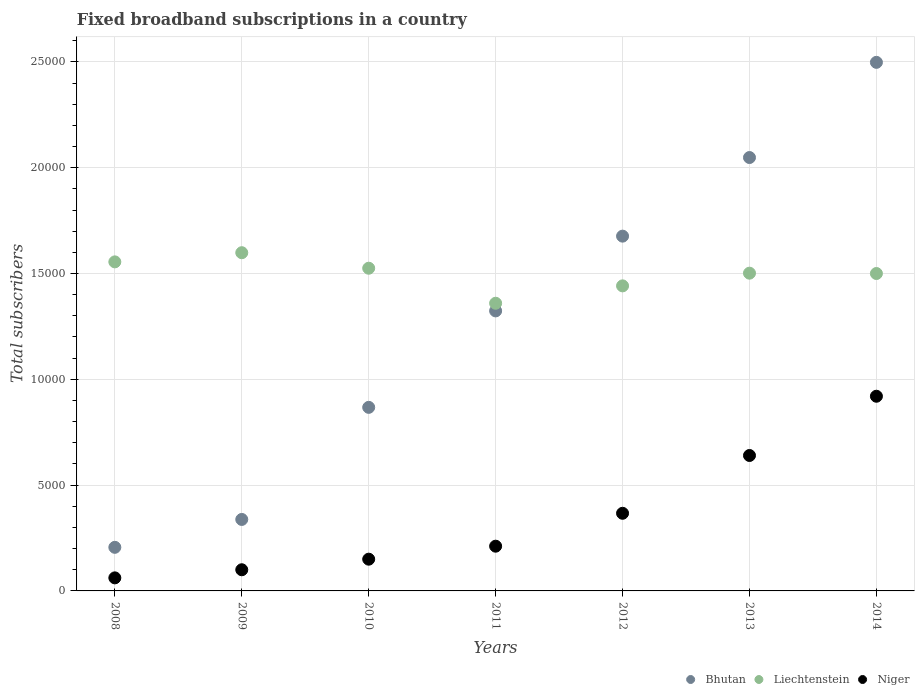How many different coloured dotlines are there?
Offer a terse response. 3. What is the number of broadband subscriptions in Niger in 2013?
Offer a very short reply. 6400. Across all years, what is the maximum number of broadband subscriptions in Liechtenstein?
Your answer should be very brief. 1.60e+04. Across all years, what is the minimum number of broadband subscriptions in Bhutan?
Make the answer very short. 2060. In which year was the number of broadband subscriptions in Niger maximum?
Keep it short and to the point. 2014. What is the total number of broadband subscriptions in Niger in the graph?
Your answer should be very brief. 2.45e+04. What is the difference between the number of broadband subscriptions in Bhutan in 2011 and that in 2014?
Your answer should be compact. -1.17e+04. What is the difference between the number of broadband subscriptions in Bhutan in 2011 and the number of broadband subscriptions in Niger in 2012?
Ensure brevity in your answer.  9564. What is the average number of broadband subscriptions in Niger per year?
Your answer should be very brief. 3500. In the year 2013, what is the difference between the number of broadband subscriptions in Liechtenstein and number of broadband subscriptions in Bhutan?
Your answer should be compact. -5465. In how many years, is the number of broadband subscriptions in Niger greater than 23000?
Offer a terse response. 0. What is the ratio of the number of broadband subscriptions in Niger in 2012 to that in 2013?
Offer a terse response. 0.57. Is the number of broadband subscriptions in Bhutan in 2011 less than that in 2013?
Provide a short and direct response. Yes. What is the difference between the highest and the second highest number of broadband subscriptions in Bhutan?
Offer a very short reply. 4498. What is the difference between the highest and the lowest number of broadband subscriptions in Niger?
Ensure brevity in your answer.  8583. In how many years, is the number of broadband subscriptions in Bhutan greater than the average number of broadband subscriptions in Bhutan taken over all years?
Your answer should be compact. 4. Does the number of broadband subscriptions in Niger monotonically increase over the years?
Provide a succinct answer. Yes. What is the difference between two consecutive major ticks on the Y-axis?
Offer a terse response. 5000. Where does the legend appear in the graph?
Offer a very short reply. Bottom right. How many legend labels are there?
Give a very brief answer. 3. What is the title of the graph?
Provide a succinct answer. Fixed broadband subscriptions in a country. Does "Kenya" appear as one of the legend labels in the graph?
Offer a very short reply. No. What is the label or title of the Y-axis?
Make the answer very short. Total subscribers. What is the Total subscribers in Bhutan in 2008?
Your response must be concise. 2060. What is the Total subscribers of Liechtenstein in 2008?
Provide a succinct answer. 1.56e+04. What is the Total subscribers of Niger in 2008?
Keep it short and to the point. 617. What is the Total subscribers in Bhutan in 2009?
Your response must be concise. 3378. What is the Total subscribers in Liechtenstein in 2009?
Provide a short and direct response. 1.60e+04. What is the Total subscribers in Niger in 2009?
Your answer should be compact. 1000. What is the Total subscribers in Bhutan in 2010?
Give a very brief answer. 8675. What is the Total subscribers in Liechtenstein in 2010?
Keep it short and to the point. 1.52e+04. What is the Total subscribers in Niger in 2010?
Offer a very short reply. 1500. What is the Total subscribers of Bhutan in 2011?
Your answer should be compact. 1.32e+04. What is the Total subscribers in Liechtenstein in 2011?
Offer a terse response. 1.36e+04. What is the Total subscribers of Niger in 2011?
Your answer should be very brief. 2114. What is the Total subscribers of Bhutan in 2012?
Offer a very short reply. 1.68e+04. What is the Total subscribers in Liechtenstein in 2012?
Offer a very short reply. 1.44e+04. What is the Total subscribers of Niger in 2012?
Make the answer very short. 3669. What is the Total subscribers in Bhutan in 2013?
Ensure brevity in your answer.  2.05e+04. What is the Total subscribers of Liechtenstein in 2013?
Offer a very short reply. 1.50e+04. What is the Total subscribers of Niger in 2013?
Make the answer very short. 6400. What is the Total subscribers of Bhutan in 2014?
Offer a terse response. 2.50e+04. What is the Total subscribers of Liechtenstein in 2014?
Offer a very short reply. 1.50e+04. What is the Total subscribers of Niger in 2014?
Give a very brief answer. 9200. Across all years, what is the maximum Total subscribers of Bhutan?
Make the answer very short. 2.50e+04. Across all years, what is the maximum Total subscribers in Liechtenstein?
Provide a short and direct response. 1.60e+04. Across all years, what is the maximum Total subscribers in Niger?
Offer a terse response. 9200. Across all years, what is the minimum Total subscribers in Bhutan?
Offer a terse response. 2060. Across all years, what is the minimum Total subscribers of Liechtenstein?
Your response must be concise. 1.36e+04. Across all years, what is the minimum Total subscribers in Niger?
Offer a terse response. 617. What is the total Total subscribers in Bhutan in the graph?
Your answer should be very brief. 8.96e+04. What is the total Total subscribers of Liechtenstein in the graph?
Provide a short and direct response. 1.05e+05. What is the total Total subscribers in Niger in the graph?
Ensure brevity in your answer.  2.45e+04. What is the difference between the Total subscribers in Bhutan in 2008 and that in 2009?
Offer a terse response. -1318. What is the difference between the Total subscribers of Liechtenstein in 2008 and that in 2009?
Offer a terse response. -433. What is the difference between the Total subscribers of Niger in 2008 and that in 2009?
Provide a short and direct response. -383. What is the difference between the Total subscribers of Bhutan in 2008 and that in 2010?
Your response must be concise. -6615. What is the difference between the Total subscribers of Liechtenstein in 2008 and that in 2010?
Ensure brevity in your answer.  300. What is the difference between the Total subscribers of Niger in 2008 and that in 2010?
Provide a short and direct response. -883. What is the difference between the Total subscribers of Bhutan in 2008 and that in 2011?
Offer a terse response. -1.12e+04. What is the difference between the Total subscribers of Liechtenstein in 2008 and that in 2011?
Ensure brevity in your answer.  1955. What is the difference between the Total subscribers of Niger in 2008 and that in 2011?
Provide a succinct answer. -1497. What is the difference between the Total subscribers of Bhutan in 2008 and that in 2012?
Offer a very short reply. -1.47e+04. What is the difference between the Total subscribers in Liechtenstein in 2008 and that in 2012?
Keep it short and to the point. 1134. What is the difference between the Total subscribers in Niger in 2008 and that in 2012?
Make the answer very short. -3052. What is the difference between the Total subscribers in Bhutan in 2008 and that in 2013?
Make the answer very short. -1.84e+04. What is the difference between the Total subscribers of Liechtenstein in 2008 and that in 2013?
Offer a very short reply. 534. What is the difference between the Total subscribers of Niger in 2008 and that in 2013?
Give a very brief answer. -5783. What is the difference between the Total subscribers of Bhutan in 2008 and that in 2014?
Provide a succinct answer. -2.29e+04. What is the difference between the Total subscribers in Liechtenstein in 2008 and that in 2014?
Give a very brief answer. 550. What is the difference between the Total subscribers of Niger in 2008 and that in 2014?
Your response must be concise. -8583. What is the difference between the Total subscribers of Bhutan in 2009 and that in 2010?
Ensure brevity in your answer.  -5297. What is the difference between the Total subscribers in Liechtenstein in 2009 and that in 2010?
Your answer should be compact. 733. What is the difference between the Total subscribers of Niger in 2009 and that in 2010?
Make the answer very short. -500. What is the difference between the Total subscribers in Bhutan in 2009 and that in 2011?
Provide a short and direct response. -9855. What is the difference between the Total subscribers in Liechtenstein in 2009 and that in 2011?
Offer a very short reply. 2388. What is the difference between the Total subscribers in Niger in 2009 and that in 2011?
Make the answer very short. -1114. What is the difference between the Total subscribers in Bhutan in 2009 and that in 2012?
Ensure brevity in your answer.  -1.34e+04. What is the difference between the Total subscribers of Liechtenstein in 2009 and that in 2012?
Make the answer very short. 1567. What is the difference between the Total subscribers in Niger in 2009 and that in 2012?
Give a very brief answer. -2669. What is the difference between the Total subscribers in Bhutan in 2009 and that in 2013?
Provide a succinct answer. -1.71e+04. What is the difference between the Total subscribers of Liechtenstein in 2009 and that in 2013?
Offer a terse response. 967. What is the difference between the Total subscribers in Niger in 2009 and that in 2013?
Your response must be concise. -5400. What is the difference between the Total subscribers in Bhutan in 2009 and that in 2014?
Make the answer very short. -2.16e+04. What is the difference between the Total subscribers of Liechtenstein in 2009 and that in 2014?
Your answer should be very brief. 983. What is the difference between the Total subscribers in Niger in 2009 and that in 2014?
Offer a terse response. -8200. What is the difference between the Total subscribers in Bhutan in 2010 and that in 2011?
Your answer should be compact. -4558. What is the difference between the Total subscribers of Liechtenstein in 2010 and that in 2011?
Provide a short and direct response. 1655. What is the difference between the Total subscribers in Niger in 2010 and that in 2011?
Offer a very short reply. -614. What is the difference between the Total subscribers of Bhutan in 2010 and that in 2012?
Make the answer very short. -8091. What is the difference between the Total subscribers of Liechtenstein in 2010 and that in 2012?
Offer a very short reply. 834. What is the difference between the Total subscribers in Niger in 2010 and that in 2012?
Your answer should be very brief. -2169. What is the difference between the Total subscribers of Bhutan in 2010 and that in 2013?
Ensure brevity in your answer.  -1.18e+04. What is the difference between the Total subscribers in Liechtenstein in 2010 and that in 2013?
Ensure brevity in your answer.  234. What is the difference between the Total subscribers of Niger in 2010 and that in 2013?
Give a very brief answer. -4900. What is the difference between the Total subscribers in Bhutan in 2010 and that in 2014?
Give a very brief answer. -1.63e+04. What is the difference between the Total subscribers in Liechtenstein in 2010 and that in 2014?
Make the answer very short. 250. What is the difference between the Total subscribers in Niger in 2010 and that in 2014?
Offer a terse response. -7700. What is the difference between the Total subscribers in Bhutan in 2011 and that in 2012?
Give a very brief answer. -3533. What is the difference between the Total subscribers of Liechtenstein in 2011 and that in 2012?
Keep it short and to the point. -821. What is the difference between the Total subscribers in Niger in 2011 and that in 2012?
Provide a short and direct response. -1555. What is the difference between the Total subscribers in Bhutan in 2011 and that in 2013?
Offer a terse response. -7248. What is the difference between the Total subscribers of Liechtenstein in 2011 and that in 2013?
Offer a terse response. -1421. What is the difference between the Total subscribers in Niger in 2011 and that in 2013?
Give a very brief answer. -4286. What is the difference between the Total subscribers in Bhutan in 2011 and that in 2014?
Give a very brief answer. -1.17e+04. What is the difference between the Total subscribers of Liechtenstein in 2011 and that in 2014?
Your answer should be very brief. -1405. What is the difference between the Total subscribers in Niger in 2011 and that in 2014?
Your answer should be very brief. -7086. What is the difference between the Total subscribers in Bhutan in 2012 and that in 2013?
Keep it short and to the point. -3715. What is the difference between the Total subscribers in Liechtenstein in 2012 and that in 2013?
Offer a very short reply. -600. What is the difference between the Total subscribers in Niger in 2012 and that in 2013?
Your response must be concise. -2731. What is the difference between the Total subscribers of Bhutan in 2012 and that in 2014?
Your response must be concise. -8213. What is the difference between the Total subscribers in Liechtenstein in 2012 and that in 2014?
Offer a terse response. -584. What is the difference between the Total subscribers in Niger in 2012 and that in 2014?
Make the answer very short. -5531. What is the difference between the Total subscribers in Bhutan in 2013 and that in 2014?
Provide a succinct answer. -4498. What is the difference between the Total subscribers of Liechtenstein in 2013 and that in 2014?
Your answer should be compact. 16. What is the difference between the Total subscribers in Niger in 2013 and that in 2014?
Provide a short and direct response. -2800. What is the difference between the Total subscribers in Bhutan in 2008 and the Total subscribers in Liechtenstein in 2009?
Your answer should be very brief. -1.39e+04. What is the difference between the Total subscribers in Bhutan in 2008 and the Total subscribers in Niger in 2009?
Keep it short and to the point. 1060. What is the difference between the Total subscribers of Liechtenstein in 2008 and the Total subscribers of Niger in 2009?
Give a very brief answer. 1.46e+04. What is the difference between the Total subscribers in Bhutan in 2008 and the Total subscribers in Liechtenstein in 2010?
Make the answer very short. -1.32e+04. What is the difference between the Total subscribers of Bhutan in 2008 and the Total subscribers of Niger in 2010?
Provide a succinct answer. 560. What is the difference between the Total subscribers of Liechtenstein in 2008 and the Total subscribers of Niger in 2010?
Offer a terse response. 1.40e+04. What is the difference between the Total subscribers of Bhutan in 2008 and the Total subscribers of Liechtenstein in 2011?
Offer a terse response. -1.15e+04. What is the difference between the Total subscribers of Bhutan in 2008 and the Total subscribers of Niger in 2011?
Give a very brief answer. -54. What is the difference between the Total subscribers in Liechtenstein in 2008 and the Total subscribers in Niger in 2011?
Provide a short and direct response. 1.34e+04. What is the difference between the Total subscribers in Bhutan in 2008 and the Total subscribers in Liechtenstein in 2012?
Provide a short and direct response. -1.24e+04. What is the difference between the Total subscribers of Bhutan in 2008 and the Total subscribers of Niger in 2012?
Give a very brief answer. -1609. What is the difference between the Total subscribers of Liechtenstein in 2008 and the Total subscribers of Niger in 2012?
Your answer should be compact. 1.19e+04. What is the difference between the Total subscribers in Bhutan in 2008 and the Total subscribers in Liechtenstein in 2013?
Make the answer very short. -1.30e+04. What is the difference between the Total subscribers of Bhutan in 2008 and the Total subscribers of Niger in 2013?
Provide a succinct answer. -4340. What is the difference between the Total subscribers in Liechtenstein in 2008 and the Total subscribers in Niger in 2013?
Make the answer very short. 9150. What is the difference between the Total subscribers in Bhutan in 2008 and the Total subscribers in Liechtenstein in 2014?
Your answer should be very brief. -1.29e+04. What is the difference between the Total subscribers of Bhutan in 2008 and the Total subscribers of Niger in 2014?
Your response must be concise. -7140. What is the difference between the Total subscribers in Liechtenstein in 2008 and the Total subscribers in Niger in 2014?
Your answer should be compact. 6350. What is the difference between the Total subscribers of Bhutan in 2009 and the Total subscribers of Liechtenstein in 2010?
Offer a very short reply. -1.19e+04. What is the difference between the Total subscribers of Bhutan in 2009 and the Total subscribers of Niger in 2010?
Give a very brief answer. 1878. What is the difference between the Total subscribers in Liechtenstein in 2009 and the Total subscribers in Niger in 2010?
Your response must be concise. 1.45e+04. What is the difference between the Total subscribers in Bhutan in 2009 and the Total subscribers in Liechtenstein in 2011?
Your answer should be very brief. -1.02e+04. What is the difference between the Total subscribers in Bhutan in 2009 and the Total subscribers in Niger in 2011?
Offer a very short reply. 1264. What is the difference between the Total subscribers in Liechtenstein in 2009 and the Total subscribers in Niger in 2011?
Provide a succinct answer. 1.39e+04. What is the difference between the Total subscribers of Bhutan in 2009 and the Total subscribers of Liechtenstein in 2012?
Ensure brevity in your answer.  -1.10e+04. What is the difference between the Total subscribers of Bhutan in 2009 and the Total subscribers of Niger in 2012?
Provide a short and direct response. -291. What is the difference between the Total subscribers of Liechtenstein in 2009 and the Total subscribers of Niger in 2012?
Keep it short and to the point. 1.23e+04. What is the difference between the Total subscribers in Bhutan in 2009 and the Total subscribers in Liechtenstein in 2013?
Your answer should be very brief. -1.16e+04. What is the difference between the Total subscribers of Bhutan in 2009 and the Total subscribers of Niger in 2013?
Provide a succinct answer. -3022. What is the difference between the Total subscribers of Liechtenstein in 2009 and the Total subscribers of Niger in 2013?
Provide a short and direct response. 9583. What is the difference between the Total subscribers of Bhutan in 2009 and the Total subscribers of Liechtenstein in 2014?
Your response must be concise. -1.16e+04. What is the difference between the Total subscribers of Bhutan in 2009 and the Total subscribers of Niger in 2014?
Your response must be concise. -5822. What is the difference between the Total subscribers of Liechtenstein in 2009 and the Total subscribers of Niger in 2014?
Make the answer very short. 6783. What is the difference between the Total subscribers of Bhutan in 2010 and the Total subscribers of Liechtenstein in 2011?
Offer a very short reply. -4920. What is the difference between the Total subscribers of Bhutan in 2010 and the Total subscribers of Niger in 2011?
Your answer should be compact. 6561. What is the difference between the Total subscribers in Liechtenstein in 2010 and the Total subscribers in Niger in 2011?
Provide a short and direct response. 1.31e+04. What is the difference between the Total subscribers in Bhutan in 2010 and the Total subscribers in Liechtenstein in 2012?
Your answer should be very brief. -5741. What is the difference between the Total subscribers of Bhutan in 2010 and the Total subscribers of Niger in 2012?
Make the answer very short. 5006. What is the difference between the Total subscribers of Liechtenstein in 2010 and the Total subscribers of Niger in 2012?
Your response must be concise. 1.16e+04. What is the difference between the Total subscribers of Bhutan in 2010 and the Total subscribers of Liechtenstein in 2013?
Offer a very short reply. -6341. What is the difference between the Total subscribers of Bhutan in 2010 and the Total subscribers of Niger in 2013?
Your answer should be compact. 2275. What is the difference between the Total subscribers of Liechtenstein in 2010 and the Total subscribers of Niger in 2013?
Give a very brief answer. 8850. What is the difference between the Total subscribers of Bhutan in 2010 and the Total subscribers of Liechtenstein in 2014?
Your response must be concise. -6325. What is the difference between the Total subscribers in Bhutan in 2010 and the Total subscribers in Niger in 2014?
Ensure brevity in your answer.  -525. What is the difference between the Total subscribers of Liechtenstein in 2010 and the Total subscribers of Niger in 2014?
Offer a terse response. 6050. What is the difference between the Total subscribers in Bhutan in 2011 and the Total subscribers in Liechtenstein in 2012?
Your answer should be compact. -1183. What is the difference between the Total subscribers of Bhutan in 2011 and the Total subscribers of Niger in 2012?
Offer a terse response. 9564. What is the difference between the Total subscribers in Liechtenstein in 2011 and the Total subscribers in Niger in 2012?
Your answer should be compact. 9926. What is the difference between the Total subscribers of Bhutan in 2011 and the Total subscribers of Liechtenstein in 2013?
Ensure brevity in your answer.  -1783. What is the difference between the Total subscribers in Bhutan in 2011 and the Total subscribers in Niger in 2013?
Offer a very short reply. 6833. What is the difference between the Total subscribers in Liechtenstein in 2011 and the Total subscribers in Niger in 2013?
Make the answer very short. 7195. What is the difference between the Total subscribers of Bhutan in 2011 and the Total subscribers of Liechtenstein in 2014?
Provide a succinct answer. -1767. What is the difference between the Total subscribers in Bhutan in 2011 and the Total subscribers in Niger in 2014?
Your answer should be very brief. 4033. What is the difference between the Total subscribers of Liechtenstein in 2011 and the Total subscribers of Niger in 2014?
Offer a very short reply. 4395. What is the difference between the Total subscribers in Bhutan in 2012 and the Total subscribers in Liechtenstein in 2013?
Offer a very short reply. 1750. What is the difference between the Total subscribers in Bhutan in 2012 and the Total subscribers in Niger in 2013?
Keep it short and to the point. 1.04e+04. What is the difference between the Total subscribers in Liechtenstein in 2012 and the Total subscribers in Niger in 2013?
Provide a succinct answer. 8016. What is the difference between the Total subscribers of Bhutan in 2012 and the Total subscribers of Liechtenstein in 2014?
Ensure brevity in your answer.  1766. What is the difference between the Total subscribers of Bhutan in 2012 and the Total subscribers of Niger in 2014?
Provide a succinct answer. 7566. What is the difference between the Total subscribers of Liechtenstein in 2012 and the Total subscribers of Niger in 2014?
Keep it short and to the point. 5216. What is the difference between the Total subscribers of Bhutan in 2013 and the Total subscribers of Liechtenstein in 2014?
Your response must be concise. 5481. What is the difference between the Total subscribers in Bhutan in 2013 and the Total subscribers in Niger in 2014?
Keep it short and to the point. 1.13e+04. What is the difference between the Total subscribers in Liechtenstein in 2013 and the Total subscribers in Niger in 2014?
Your answer should be compact. 5816. What is the average Total subscribers in Bhutan per year?
Ensure brevity in your answer.  1.28e+04. What is the average Total subscribers of Liechtenstein per year?
Offer a terse response. 1.50e+04. What is the average Total subscribers in Niger per year?
Keep it short and to the point. 3500. In the year 2008, what is the difference between the Total subscribers in Bhutan and Total subscribers in Liechtenstein?
Provide a succinct answer. -1.35e+04. In the year 2008, what is the difference between the Total subscribers in Bhutan and Total subscribers in Niger?
Your response must be concise. 1443. In the year 2008, what is the difference between the Total subscribers of Liechtenstein and Total subscribers of Niger?
Provide a succinct answer. 1.49e+04. In the year 2009, what is the difference between the Total subscribers in Bhutan and Total subscribers in Liechtenstein?
Ensure brevity in your answer.  -1.26e+04. In the year 2009, what is the difference between the Total subscribers in Bhutan and Total subscribers in Niger?
Offer a very short reply. 2378. In the year 2009, what is the difference between the Total subscribers of Liechtenstein and Total subscribers of Niger?
Provide a short and direct response. 1.50e+04. In the year 2010, what is the difference between the Total subscribers in Bhutan and Total subscribers in Liechtenstein?
Provide a short and direct response. -6575. In the year 2010, what is the difference between the Total subscribers in Bhutan and Total subscribers in Niger?
Offer a terse response. 7175. In the year 2010, what is the difference between the Total subscribers of Liechtenstein and Total subscribers of Niger?
Provide a succinct answer. 1.38e+04. In the year 2011, what is the difference between the Total subscribers of Bhutan and Total subscribers of Liechtenstein?
Your answer should be compact. -362. In the year 2011, what is the difference between the Total subscribers in Bhutan and Total subscribers in Niger?
Make the answer very short. 1.11e+04. In the year 2011, what is the difference between the Total subscribers in Liechtenstein and Total subscribers in Niger?
Make the answer very short. 1.15e+04. In the year 2012, what is the difference between the Total subscribers in Bhutan and Total subscribers in Liechtenstein?
Provide a succinct answer. 2350. In the year 2012, what is the difference between the Total subscribers of Bhutan and Total subscribers of Niger?
Provide a short and direct response. 1.31e+04. In the year 2012, what is the difference between the Total subscribers of Liechtenstein and Total subscribers of Niger?
Ensure brevity in your answer.  1.07e+04. In the year 2013, what is the difference between the Total subscribers in Bhutan and Total subscribers in Liechtenstein?
Your response must be concise. 5465. In the year 2013, what is the difference between the Total subscribers in Bhutan and Total subscribers in Niger?
Your answer should be compact. 1.41e+04. In the year 2013, what is the difference between the Total subscribers of Liechtenstein and Total subscribers of Niger?
Provide a succinct answer. 8616. In the year 2014, what is the difference between the Total subscribers in Bhutan and Total subscribers in Liechtenstein?
Your answer should be very brief. 9979. In the year 2014, what is the difference between the Total subscribers of Bhutan and Total subscribers of Niger?
Your response must be concise. 1.58e+04. In the year 2014, what is the difference between the Total subscribers of Liechtenstein and Total subscribers of Niger?
Your response must be concise. 5800. What is the ratio of the Total subscribers of Bhutan in 2008 to that in 2009?
Keep it short and to the point. 0.61. What is the ratio of the Total subscribers in Liechtenstein in 2008 to that in 2009?
Ensure brevity in your answer.  0.97. What is the ratio of the Total subscribers in Niger in 2008 to that in 2009?
Ensure brevity in your answer.  0.62. What is the ratio of the Total subscribers in Bhutan in 2008 to that in 2010?
Your answer should be compact. 0.24. What is the ratio of the Total subscribers in Liechtenstein in 2008 to that in 2010?
Your response must be concise. 1.02. What is the ratio of the Total subscribers in Niger in 2008 to that in 2010?
Your answer should be compact. 0.41. What is the ratio of the Total subscribers in Bhutan in 2008 to that in 2011?
Provide a succinct answer. 0.16. What is the ratio of the Total subscribers of Liechtenstein in 2008 to that in 2011?
Keep it short and to the point. 1.14. What is the ratio of the Total subscribers of Niger in 2008 to that in 2011?
Provide a short and direct response. 0.29. What is the ratio of the Total subscribers of Bhutan in 2008 to that in 2012?
Offer a terse response. 0.12. What is the ratio of the Total subscribers of Liechtenstein in 2008 to that in 2012?
Your answer should be very brief. 1.08. What is the ratio of the Total subscribers of Niger in 2008 to that in 2012?
Keep it short and to the point. 0.17. What is the ratio of the Total subscribers of Bhutan in 2008 to that in 2013?
Offer a terse response. 0.1. What is the ratio of the Total subscribers of Liechtenstein in 2008 to that in 2013?
Offer a terse response. 1.04. What is the ratio of the Total subscribers of Niger in 2008 to that in 2013?
Keep it short and to the point. 0.1. What is the ratio of the Total subscribers in Bhutan in 2008 to that in 2014?
Provide a succinct answer. 0.08. What is the ratio of the Total subscribers in Liechtenstein in 2008 to that in 2014?
Give a very brief answer. 1.04. What is the ratio of the Total subscribers of Niger in 2008 to that in 2014?
Provide a short and direct response. 0.07. What is the ratio of the Total subscribers in Bhutan in 2009 to that in 2010?
Provide a short and direct response. 0.39. What is the ratio of the Total subscribers in Liechtenstein in 2009 to that in 2010?
Your answer should be very brief. 1.05. What is the ratio of the Total subscribers of Niger in 2009 to that in 2010?
Ensure brevity in your answer.  0.67. What is the ratio of the Total subscribers of Bhutan in 2009 to that in 2011?
Offer a terse response. 0.26. What is the ratio of the Total subscribers in Liechtenstein in 2009 to that in 2011?
Offer a terse response. 1.18. What is the ratio of the Total subscribers of Niger in 2009 to that in 2011?
Your answer should be very brief. 0.47. What is the ratio of the Total subscribers in Bhutan in 2009 to that in 2012?
Provide a short and direct response. 0.2. What is the ratio of the Total subscribers of Liechtenstein in 2009 to that in 2012?
Your response must be concise. 1.11. What is the ratio of the Total subscribers of Niger in 2009 to that in 2012?
Make the answer very short. 0.27. What is the ratio of the Total subscribers in Bhutan in 2009 to that in 2013?
Your answer should be very brief. 0.16. What is the ratio of the Total subscribers of Liechtenstein in 2009 to that in 2013?
Your answer should be very brief. 1.06. What is the ratio of the Total subscribers of Niger in 2009 to that in 2013?
Your response must be concise. 0.16. What is the ratio of the Total subscribers in Bhutan in 2009 to that in 2014?
Ensure brevity in your answer.  0.14. What is the ratio of the Total subscribers of Liechtenstein in 2009 to that in 2014?
Make the answer very short. 1.07. What is the ratio of the Total subscribers of Niger in 2009 to that in 2014?
Keep it short and to the point. 0.11. What is the ratio of the Total subscribers in Bhutan in 2010 to that in 2011?
Make the answer very short. 0.66. What is the ratio of the Total subscribers of Liechtenstein in 2010 to that in 2011?
Offer a terse response. 1.12. What is the ratio of the Total subscribers of Niger in 2010 to that in 2011?
Give a very brief answer. 0.71. What is the ratio of the Total subscribers of Bhutan in 2010 to that in 2012?
Offer a terse response. 0.52. What is the ratio of the Total subscribers of Liechtenstein in 2010 to that in 2012?
Provide a succinct answer. 1.06. What is the ratio of the Total subscribers of Niger in 2010 to that in 2012?
Your answer should be compact. 0.41. What is the ratio of the Total subscribers of Bhutan in 2010 to that in 2013?
Offer a very short reply. 0.42. What is the ratio of the Total subscribers in Liechtenstein in 2010 to that in 2013?
Give a very brief answer. 1.02. What is the ratio of the Total subscribers of Niger in 2010 to that in 2013?
Ensure brevity in your answer.  0.23. What is the ratio of the Total subscribers in Bhutan in 2010 to that in 2014?
Make the answer very short. 0.35. What is the ratio of the Total subscribers of Liechtenstein in 2010 to that in 2014?
Give a very brief answer. 1.02. What is the ratio of the Total subscribers of Niger in 2010 to that in 2014?
Offer a very short reply. 0.16. What is the ratio of the Total subscribers of Bhutan in 2011 to that in 2012?
Ensure brevity in your answer.  0.79. What is the ratio of the Total subscribers in Liechtenstein in 2011 to that in 2012?
Your response must be concise. 0.94. What is the ratio of the Total subscribers of Niger in 2011 to that in 2012?
Your answer should be very brief. 0.58. What is the ratio of the Total subscribers of Bhutan in 2011 to that in 2013?
Keep it short and to the point. 0.65. What is the ratio of the Total subscribers of Liechtenstein in 2011 to that in 2013?
Make the answer very short. 0.91. What is the ratio of the Total subscribers of Niger in 2011 to that in 2013?
Provide a short and direct response. 0.33. What is the ratio of the Total subscribers of Bhutan in 2011 to that in 2014?
Your response must be concise. 0.53. What is the ratio of the Total subscribers of Liechtenstein in 2011 to that in 2014?
Offer a very short reply. 0.91. What is the ratio of the Total subscribers of Niger in 2011 to that in 2014?
Your answer should be compact. 0.23. What is the ratio of the Total subscribers in Bhutan in 2012 to that in 2013?
Keep it short and to the point. 0.82. What is the ratio of the Total subscribers of Niger in 2012 to that in 2013?
Offer a terse response. 0.57. What is the ratio of the Total subscribers in Bhutan in 2012 to that in 2014?
Provide a succinct answer. 0.67. What is the ratio of the Total subscribers of Liechtenstein in 2012 to that in 2014?
Your response must be concise. 0.96. What is the ratio of the Total subscribers in Niger in 2012 to that in 2014?
Your response must be concise. 0.4. What is the ratio of the Total subscribers in Bhutan in 2013 to that in 2014?
Keep it short and to the point. 0.82. What is the ratio of the Total subscribers of Liechtenstein in 2013 to that in 2014?
Your answer should be compact. 1. What is the ratio of the Total subscribers of Niger in 2013 to that in 2014?
Give a very brief answer. 0.7. What is the difference between the highest and the second highest Total subscribers of Bhutan?
Give a very brief answer. 4498. What is the difference between the highest and the second highest Total subscribers in Liechtenstein?
Provide a succinct answer. 433. What is the difference between the highest and the second highest Total subscribers in Niger?
Provide a short and direct response. 2800. What is the difference between the highest and the lowest Total subscribers in Bhutan?
Provide a succinct answer. 2.29e+04. What is the difference between the highest and the lowest Total subscribers of Liechtenstein?
Give a very brief answer. 2388. What is the difference between the highest and the lowest Total subscribers in Niger?
Your response must be concise. 8583. 